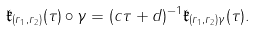Convert formula to latex. <formula><loc_0><loc_0><loc_500><loc_500>\mathfrak { k } _ { ( r _ { 1 } , r _ { 2 } ) } ( \tau ) \circ \gamma = ( c \tau + d ) ^ { - 1 } \mathfrak { k } _ { ( r _ { 1 } , r _ { 2 } ) \gamma } ( \tau ) .</formula> 